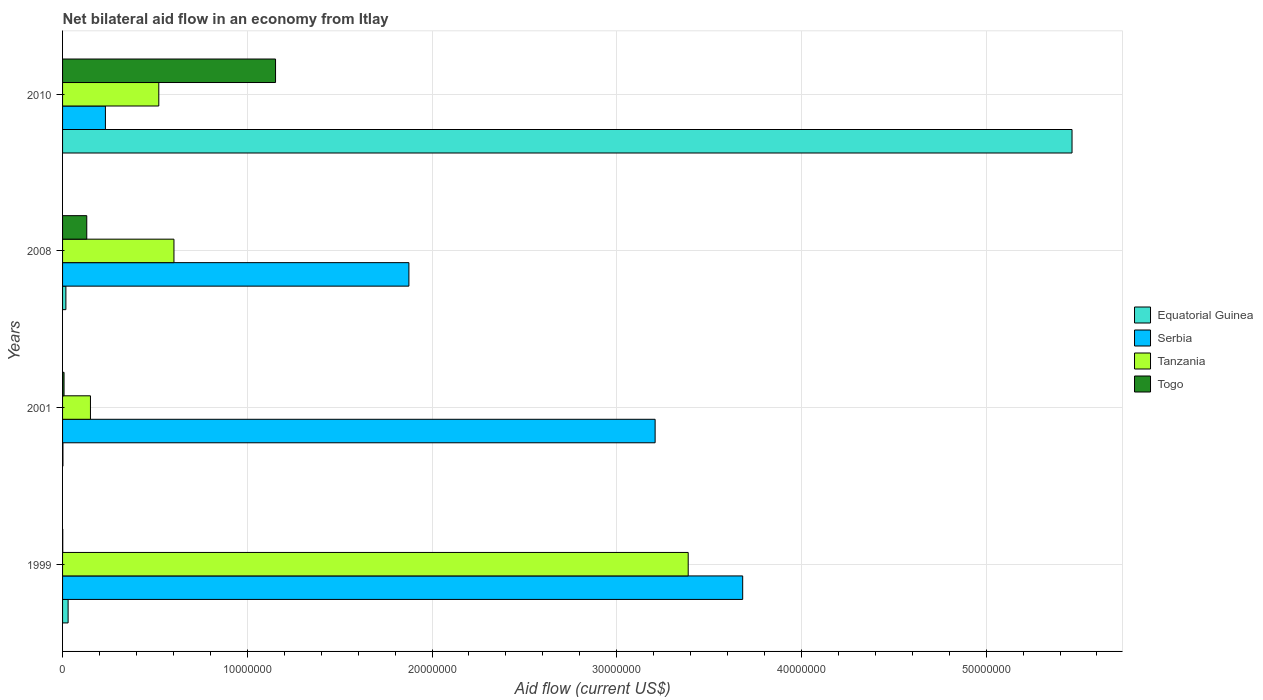How many different coloured bars are there?
Keep it short and to the point. 4. How many groups of bars are there?
Your answer should be compact. 4. Are the number of bars per tick equal to the number of legend labels?
Your response must be concise. Yes. How many bars are there on the 3rd tick from the top?
Offer a very short reply. 4. How many bars are there on the 4th tick from the bottom?
Offer a terse response. 4. What is the label of the 3rd group of bars from the top?
Provide a succinct answer. 2001. In how many cases, is the number of bars for a given year not equal to the number of legend labels?
Make the answer very short. 0. What is the net bilateral aid flow in Togo in 2008?
Ensure brevity in your answer.  1.31e+06. Across all years, what is the maximum net bilateral aid flow in Tanzania?
Give a very brief answer. 3.39e+07. Across all years, what is the minimum net bilateral aid flow in Equatorial Guinea?
Ensure brevity in your answer.  2.00e+04. In which year was the net bilateral aid flow in Togo maximum?
Your response must be concise. 2010. In which year was the net bilateral aid flow in Equatorial Guinea minimum?
Keep it short and to the point. 2001. What is the total net bilateral aid flow in Togo in the graph?
Give a very brief answer. 1.29e+07. What is the difference between the net bilateral aid flow in Serbia in 2001 and that in 2008?
Offer a very short reply. 1.33e+07. What is the difference between the net bilateral aid flow in Serbia in 1999 and the net bilateral aid flow in Equatorial Guinea in 2001?
Your response must be concise. 3.68e+07. What is the average net bilateral aid flow in Tanzania per year?
Your answer should be compact. 1.17e+07. In the year 2010, what is the difference between the net bilateral aid flow in Serbia and net bilateral aid flow in Equatorial Guinea?
Make the answer very short. -5.23e+07. What is the ratio of the net bilateral aid flow in Togo in 2001 to that in 2010?
Provide a short and direct response. 0.01. Is the difference between the net bilateral aid flow in Serbia in 2008 and 2010 greater than the difference between the net bilateral aid flow in Equatorial Guinea in 2008 and 2010?
Offer a very short reply. Yes. What is the difference between the highest and the second highest net bilateral aid flow in Tanzania?
Offer a very short reply. 2.78e+07. What is the difference between the highest and the lowest net bilateral aid flow in Togo?
Provide a short and direct response. 1.15e+07. Is the sum of the net bilateral aid flow in Equatorial Guinea in 1999 and 2008 greater than the maximum net bilateral aid flow in Togo across all years?
Provide a short and direct response. No. Is it the case that in every year, the sum of the net bilateral aid flow in Tanzania and net bilateral aid flow in Togo is greater than the sum of net bilateral aid flow in Serbia and net bilateral aid flow in Equatorial Guinea?
Offer a very short reply. No. What does the 1st bar from the top in 2008 represents?
Offer a terse response. Togo. What does the 2nd bar from the bottom in 2001 represents?
Make the answer very short. Serbia. What is the difference between two consecutive major ticks on the X-axis?
Offer a very short reply. 1.00e+07. Are the values on the major ticks of X-axis written in scientific E-notation?
Provide a short and direct response. No. Where does the legend appear in the graph?
Give a very brief answer. Center right. How many legend labels are there?
Make the answer very short. 4. How are the legend labels stacked?
Your answer should be compact. Vertical. What is the title of the graph?
Provide a succinct answer. Net bilateral aid flow in an economy from Itlay. What is the label or title of the X-axis?
Provide a short and direct response. Aid flow (current US$). What is the label or title of the Y-axis?
Offer a very short reply. Years. What is the Aid flow (current US$) in Serbia in 1999?
Keep it short and to the point. 3.68e+07. What is the Aid flow (current US$) in Tanzania in 1999?
Keep it short and to the point. 3.39e+07. What is the Aid flow (current US$) in Serbia in 2001?
Ensure brevity in your answer.  3.21e+07. What is the Aid flow (current US$) in Tanzania in 2001?
Your answer should be compact. 1.51e+06. What is the Aid flow (current US$) of Togo in 2001?
Make the answer very short. 8.00e+04. What is the Aid flow (current US$) in Serbia in 2008?
Keep it short and to the point. 1.88e+07. What is the Aid flow (current US$) of Tanzania in 2008?
Make the answer very short. 6.03e+06. What is the Aid flow (current US$) in Togo in 2008?
Your answer should be compact. 1.31e+06. What is the Aid flow (current US$) of Equatorial Guinea in 2010?
Your answer should be very brief. 5.46e+07. What is the Aid flow (current US$) of Serbia in 2010?
Your answer should be compact. 2.32e+06. What is the Aid flow (current US$) of Tanzania in 2010?
Your answer should be compact. 5.21e+06. What is the Aid flow (current US$) of Togo in 2010?
Offer a very short reply. 1.15e+07. Across all years, what is the maximum Aid flow (current US$) of Equatorial Guinea?
Give a very brief answer. 5.46e+07. Across all years, what is the maximum Aid flow (current US$) in Serbia?
Your answer should be compact. 3.68e+07. Across all years, what is the maximum Aid flow (current US$) of Tanzania?
Ensure brevity in your answer.  3.39e+07. Across all years, what is the maximum Aid flow (current US$) of Togo?
Your response must be concise. 1.15e+07. Across all years, what is the minimum Aid flow (current US$) of Serbia?
Provide a succinct answer. 2.32e+06. Across all years, what is the minimum Aid flow (current US$) of Tanzania?
Make the answer very short. 1.51e+06. Across all years, what is the minimum Aid flow (current US$) of Togo?
Provide a short and direct response. 10000. What is the total Aid flow (current US$) of Equatorial Guinea in the graph?
Offer a terse response. 5.52e+07. What is the total Aid flow (current US$) in Serbia in the graph?
Ensure brevity in your answer.  9.00e+07. What is the total Aid flow (current US$) in Tanzania in the graph?
Offer a very short reply. 4.66e+07. What is the total Aid flow (current US$) of Togo in the graph?
Ensure brevity in your answer.  1.29e+07. What is the difference between the Aid flow (current US$) in Equatorial Guinea in 1999 and that in 2001?
Provide a short and direct response. 2.80e+05. What is the difference between the Aid flow (current US$) of Serbia in 1999 and that in 2001?
Ensure brevity in your answer.  4.74e+06. What is the difference between the Aid flow (current US$) of Tanzania in 1999 and that in 2001?
Your response must be concise. 3.24e+07. What is the difference between the Aid flow (current US$) of Togo in 1999 and that in 2001?
Offer a terse response. -7.00e+04. What is the difference between the Aid flow (current US$) of Serbia in 1999 and that in 2008?
Make the answer very short. 1.81e+07. What is the difference between the Aid flow (current US$) of Tanzania in 1999 and that in 2008?
Your answer should be compact. 2.78e+07. What is the difference between the Aid flow (current US$) in Togo in 1999 and that in 2008?
Make the answer very short. -1.30e+06. What is the difference between the Aid flow (current US$) of Equatorial Guinea in 1999 and that in 2010?
Offer a terse response. -5.44e+07. What is the difference between the Aid flow (current US$) of Serbia in 1999 and that in 2010?
Offer a very short reply. 3.45e+07. What is the difference between the Aid flow (current US$) of Tanzania in 1999 and that in 2010?
Provide a short and direct response. 2.87e+07. What is the difference between the Aid flow (current US$) in Togo in 1999 and that in 2010?
Keep it short and to the point. -1.15e+07. What is the difference between the Aid flow (current US$) of Equatorial Guinea in 2001 and that in 2008?
Your response must be concise. -1.60e+05. What is the difference between the Aid flow (current US$) in Serbia in 2001 and that in 2008?
Make the answer very short. 1.33e+07. What is the difference between the Aid flow (current US$) of Tanzania in 2001 and that in 2008?
Offer a terse response. -4.52e+06. What is the difference between the Aid flow (current US$) of Togo in 2001 and that in 2008?
Keep it short and to the point. -1.23e+06. What is the difference between the Aid flow (current US$) of Equatorial Guinea in 2001 and that in 2010?
Your response must be concise. -5.46e+07. What is the difference between the Aid flow (current US$) in Serbia in 2001 and that in 2010?
Your answer should be compact. 2.98e+07. What is the difference between the Aid flow (current US$) in Tanzania in 2001 and that in 2010?
Ensure brevity in your answer.  -3.70e+06. What is the difference between the Aid flow (current US$) of Togo in 2001 and that in 2010?
Your answer should be very brief. -1.14e+07. What is the difference between the Aid flow (current US$) in Equatorial Guinea in 2008 and that in 2010?
Your answer should be very brief. -5.45e+07. What is the difference between the Aid flow (current US$) of Serbia in 2008 and that in 2010?
Your answer should be compact. 1.64e+07. What is the difference between the Aid flow (current US$) in Tanzania in 2008 and that in 2010?
Ensure brevity in your answer.  8.20e+05. What is the difference between the Aid flow (current US$) of Togo in 2008 and that in 2010?
Your answer should be very brief. -1.02e+07. What is the difference between the Aid flow (current US$) in Equatorial Guinea in 1999 and the Aid flow (current US$) in Serbia in 2001?
Offer a terse response. -3.18e+07. What is the difference between the Aid flow (current US$) in Equatorial Guinea in 1999 and the Aid flow (current US$) in Tanzania in 2001?
Make the answer very short. -1.21e+06. What is the difference between the Aid flow (current US$) of Equatorial Guinea in 1999 and the Aid flow (current US$) of Togo in 2001?
Offer a very short reply. 2.20e+05. What is the difference between the Aid flow (current US$) in Serbia in 1999 and the Aid flow (current US$) in Tanzania in 2001?
Provide a short and direct response. 3.53e+07. What is the difference between the Aid flow (current US$) in Serbia in 1999 and the Aid flow (current US$) in Togo in 2001?
Your answer should be very brief. 3.67e+07. What is the difference between the Aid flow (current US$) of Tanzania in 1999 and the Aid flow (current US$) of Togo in 2001?
Give a very brief answer. 3.38e+07. What is the difference between the Aid flow (current US$) in Equatorial Guinea in 1999 and the Aid flow (current US$) in Serbia in 2008?
Offer a terse response. -1.84e+07. What is the difference between the Aid flow (current US$) of Equatorial Guinea in 1999 and the Aid flow (current US$) of Tanzania in 2008?
Offer a terse response. -5.73e+06. What is the difference between the Aid flow (current US$) of Equatorial Guinea in 1999 and the Aid flow (current US$) of Togo in 2008?
Offer a terse response. -1.01e+06. What is the difference between the Aid flow (current US$) in Serbia in 1999 and the Aid flow (current US$) in Tanzania in 2008?
Your answer should be compact. 3.08e+07. What is the difference between the Aid flow (current US$) in Serbia in 1999 and the Aid flow (current US$) in Togo in 2008?
Your answer should be very brief. 3.55e+07. What is the difference between the Aid flow (current US$) of Tanzania in 1999 and the Aid flow (current US$) of Togo in 2008?
Offer a terse response. 3.26e+07. What is the difference between the Aid flow (current US$) of Equatorial Guinea in 1999 and the Aid flow (current US$) of Serbia in 2010?
Your response must be concise. -2.02e+06. What is the difference between the Aid flow (current US$) of Equatorial Guinea in 1999 and the Aid flow (current US$) of Tanzania in 2010?
Give a very brief answer. -4.91e+06. What is the difference between the Aid flow (current US$) in Equatorial Guinea in 1999 and the Aid flow (current US$) in Togo in 2010?
Offer a very short reply. -1.12e+07. What is the difference between the Aid flow (current US$) in Serbia in 1999 and the Aid flow (current US$) in Tanzania in 2010?
Offer a very short reply. 3.16e+07. What is the difference between the Aid flow (current US$) in Serbia in 1999 and the Aid flow (current US$) in Togo in 2010?
Provide a succinct answer. 2.53e+07. What is the difference between the Aid flow (current US$) in Tanzania in 1999 and the Aid flow (current US$) in Togo in 2010?
Provide a succinct answer. 2.23e+07. What is the difference between the Aid flow (current US$) of Equatorial Guinea in 2001 and the Aid flow (current US$) of Serbia in 2008?
Make the answer very short. -1.87e+07. What is the difference between the Aid flow (current US$) in Equatorial Guinea in 2001 and the Aid flow (current US$) in Tanzania in 2008?
Provide a succinct answer. -6.01e+06. What is the difference between the Aid flow (current US$) of Equatorial Guinea in 2001 and the Aid flow (current US$) of Togo in 2008?
Your answer should be compact. -1.29e+06. What is the difference between the Aid flow (current US$) in Serbia in 2001 and the Aid flow (current US$) in Tanzania in 2008?
Provide a succinct answer. 2.60e+07. What is the difference between the Aid flow (current US$) in Serbia in 2001 and the Aid flow (current US$) in Togo in 2008?
Your answer should be very brief. 3.08e+07. What is the difference between the Aid flow (current US$) in Tanzania in 2001 and the Aid flow (current US$) in Togo in 2008?
Your response must be concise. 2.00e+05. What is the difference between the Aid flow (current US$) in Equatorial Guinea in 2001 and the Aid flow (current US$) in Serbia in 2010?
Make the answer very short. -2.30e+06. What is the difference between the Aid flow (current US$) of Equatorial Guinea in 2001 and the Aid flow (current US$) of Tanzania in 2010?
Keep it short and to the point. -5.19e+06. What is the difference between the Aid flow (current US$) of Equatorial Guinea in 2001 and the Aid flow (current US$) of Togo in 2010?
Ensure brevity in your answer.  -1.15e+07. What is the difference between the Aid flow (current US$) of Serbia in 2001 and the Aid flow (current US$) of Tanzania in 2010?
Give a very brief answer. 2.69e+07. What is the difference between the Aid flow (current US$) of Serbia in 2001 and the Aid flow (current US$) of Togo in 2010?
Provide a succinct answer. 2.06e+07. What is the difference between the Aid flow (current US$) in Tanzania in 2001 and the Aid flow (current US$) in Togo in 2010?
Your response must be concise. -1.00e+07. What is the difference between the Aid flow (current US$) of Equatorial Guinea in 2008 and the Aid flow (current US$) of Serbia in 2010?
Offer a terse response. -2.14e+06. What is the difference between the Aid flow (current US$) of Equatorial Guinea in 2008 and the Aid flow (current US$) of Tanzania in 2010?
Your answer should be compact. -5.03e+06. What is the difference between the Aid flow (current US$) of Equatorial Guinea in 2008 and the Aid flow (current US$) of Togo in 2010?
Your answer should be compact. -1.14e+07. What is the difference between the Aid flow (current US$) in Serbia in 2008 and the Aid flow (current US$) in Tanzania in 2010?
Your answer should be very brief. 1.35e+07. What is the difference between the Aid flow (current US$) of Serbia in 2008 and the Aid flow (current US$) of Togo in 2010?
Your response must be concise. 7.22e+06. What is the difference between the Aid flow (current US$) in Tanzania in 2008 and the Aid flow (current US$) in Togo in 2010?
Provide a succinct answer. -5.50e+06. What is the average Aid flow (current US$) in Equatorial Guinea per year?
Keep it short and to the point. 1.38e+07. What is the average Aid flow (current US$) of Serbia per year?
Your answer should be compact. 2.25e+07. What is the average Aid flow (current US$) of Tanzania per year?
Keep it short and to the point. 1.17e+07. What is the average Aid flow (current US$) of Togo per year?
Your answer should be very brief. 3.23e+06. In the year 1999, what is the difference between the Aid flow (current US$) of Equatorial Guinea and Aid flow (current US$) of Serbia?
Give a very brief answer. -3.65e+07. In the year 1999, what is the difference between the Aid flow (current US$) of Equatorial Guinea and Aid flow (current US$) of Tanzania?
Provide a short and direct response. -3.36e+07. In the year 1999, what is the difference between the Aid flow (current US$) in Equatorial Guinea and Aid flow (current US$) in Togo?
Your response must be concise. 2.90e+05. In the year 1999, what is the difference between the Aid flow (current US$) of Serbia and Aid flow (current US$) of Tanzania?
Provide a short and direct response. 2.95e+06. In the year 1999, what is the difference between the Aid flow (current US$) of Serbia and Aid flow (current US$) of Togo?
Your answer should be very brief. 3.68e+07. In the year 1999, what is the difference between the Aid flow (current US$) of Tanzania and Aid flow (current US$) of Togo?
Offer a terse response. 3.39e+07. In the year 2001, what is the difference between the Aid flow (current US$) in Equatorial Guinea and Aid flow (current US$) in Serbia?
Keep it short and to the point. -3.21e+07. In the year 2001, what is the difference between the Aid flow (current US$) of Equatorial Guinea and Aid flow (current US$) of Tanzania?
Provide a succinct answer. -1.49e+06. In the year 2001, what is the difference between the Aid flow (current US$) of Serbia and Aid flow (current US$) of Tanzania?
Make the answer very short. 3.06e+07. In the year 2001, what is the difference between the Aid flow (current US$) in Serbia and Aid flow (current US$) in Togo?
Provide a succinct answer. 3.20e+07. In the year 2001, what is the difference between the Aid flow (current US$) in Tanzania and Aid flow (current US$) in Togo?
Give a very brief answer. 1.43e+06. In the year 2008, what is the difference between the Aid flow (current US$) of Equatorial Guinea and Aid flow (current US$) of Serbia?
Keep it short and to the point. -1.86e+07. In the year 2008, what is the difference between the Aid flow (current US$) in Equatorial Guinea and Aid flow (current US$) in Tanzania?
Offer a terse response. -5.85e+06. In the year 2008, what is the difference between the Aid flow (current US$) of Equatorial Guinea and Aid flow (current US$) of Togo?
Your response must be concise. -1.13e+06. In the year 2008, what is the difference between the Aid flow (current US$) of Serbia and Aid flow (current US$) of Tanzania?
Keep it short and to the point. 1.27e+07. In the year 2008, what is the difference between the Aid flow (current US$) in Serbia and Aid flow (current US$) in Togo?
Your answer should be compact. 1.74e+07. In the year 2008, what is the difference between the Aid flow (current US$) in Tanzania and Aid flow (current US$) in Togo?
Keep it short and to the point. 4.72e+06. In the year 2010, what is the difference between the Aid flow (current US$) of Equatorial Guinea and Aid flow (current US$) of Serbia?
Your answer should be compact. 5.23e+07. In the year 2010, what is the difference between the Aid flow (current US$) in Equatorial Guinea and Aid flow (current US$) in Tanzania?
Give a very brief answer. 4.94e+07. In the year 2010, what is the difference between the Aid flow (current US$) of Equatorial Guinea and Aid flow (current US$) of Togo?
Ensure brevity in your answer.  4.31e+07. In the year 2010, what is the difference between the Aid flow (current US$) of Serbia and Aid flow (current US$) of Tanzania?
Keep it short and to the point. -2.89e+06. In the year 2010, what is the difference between the Aid flow (current US$) in Serbia and Aid flow (current US$) in Togo?
Give a very brief answer. -9.21e+06. In the year 2010, what is the difference between the Aid flow (current US$) in Tanzania and Aid flow (current US$) in Togo?
Provide a succinct answer. -6.32e+06. What is the ratio of the Aid flow (current US$) of Serbia in 1999 to that in 2001?
Ensure brevity in your answer.  1.15. What is the ratio of the Aid flow (current US$) of Tanzania in 1999 to that in 2001?
Your answer should be compact. 22.43. What is the ratio of the Aid flow (current US$) of Equatorial Guinea in 1999 to that in 2008?
Your answer should be very brief. 1.67. What is the ratio of the Aid flow (current US$) in Serbia in 1999 to that in 2008?
Ensure brevity in your answer.  1.96. What is the ratio of the Aid flow (current US$) of Tanzania in 1999 to that in 2008?
Your response must be concise. 5.62. What is the ratio of the Aid flow (current US$) in Togo in 1999 to that in 2008?
Offer a terse response. 0.01. What is the ratio of the Aid flow (current US$) of Equatorial Guinea in 1999 to that in 2010?
Keep it short and to the point. 0.01. What is the ratio of the Aid flow (current US$) of Serbia in 1999 to that in 2010?
Provide a short and direct response. 15.87. What is the ratio of the Aid flow (current US$) of Tanzania in 1999 to that in 2010?
Keep it short and to the point. 6.5. What is the ratio of the Aid flow (current US$) in Togo in 1999 to that in 2010?
Provide a short and direct response. 0. What is the ratio of the Aid flow (current US$) of Equatorial Guinea in 2001 to that in 2008?
Offer a terse response. 0.11. What is the ratio of the Aid flow (current US$) of Serbia in 2001 to that in 2008?
Provide a succinct answer. 1.71. What is the ratio of the Aid flow (current US$) of Tanzania in 2001 to that in 2008?
Your response must be concise. 0.25. What is the ratio of the Aid flow (current US$) of Togo in 2001 to that in 2008?
Provide a short and direct response. 0.06. What is the ratio of the Aid flow (current US$) of Equatorial Guinea in 2001 to that in 2010?
Your response must be concise. 0. What is the ratio of the Aid flow (current US$) of Serbia in 2001 to that in 2010?
Make the answer very short. 13.83. What is the ratio of the Aid flow (current US$) of Tanzania in 2001 to that in 2010?
Ensure brevity in your answer.  0.29. What is the ratio of the Aid flow (current US$) in Togo in 2001 to that in 2010?
Offer a very short reply. 0.01. What is the ratio of the Aid flow (current US$) in Equatorial Guinea in 2008 to that in 2010?
Ensure brevity in your answer.  0. What is the ratio of the Aid flow (current US$) of Serbia in 2008 to that in 2010?
Your answer should be compact. 8.08. What is the ratio of the Aid flow (current US$) of Tanzania in 2008 to that in 2010?
Your response must be concise. 1.16. What is the ratio of the Aid flow (current US$) in Togo in 2008 to that in 2010?
Provide a short and direct response. 0.11. What is the difference between the highest and the second highest Aid flow (current US$) of Equatorial Guinea?
Make the answer very short. 5.44e+07. What is the difference between the highest and the second highest Aid flow (current US$) in Serbia?
Your answer should be very brief. 4.74e+06. What is the difference between the highest and the second highest Aid flow (current US$) in Tanzania?
Ensure brevity in your answer.  2.78e+07. What is the difference between the highest and the second highest Aid flow (current US$) of Togo?
Your answer should be compact. 1.02e+07. What is the difference between the highest and the lowest Aid flow (current US$) in Equatorial Guinea?
Make the answer very short. 5.46e+07. What is the difference between the highest and the lowest Aid flow (current US$) of Serbia?
Offer a terse response. 3.45e+07. What is the difference between the highest and the lowest Aid flow (current US$) in Tanzania?
Your response must be concise. 3.24e+07. What is the difference between the highest and the lowest Aid flow (current US$) of Togo?
Ensure brevity in your answer.  1.15e+07. 